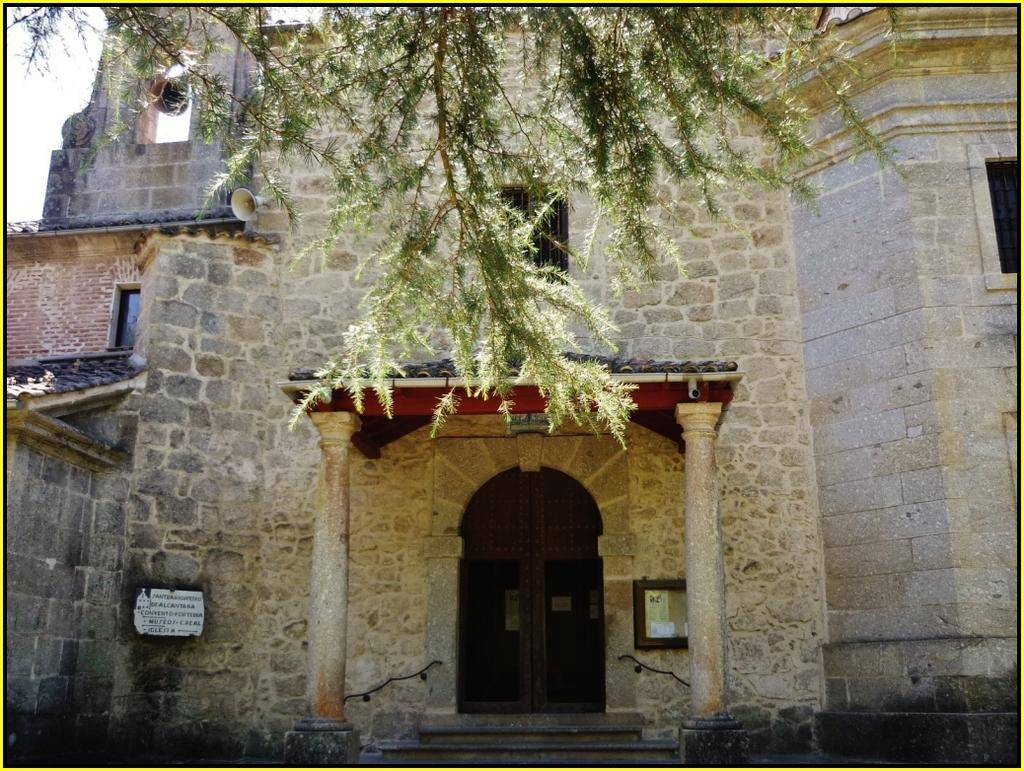What type of structure is present in the image? The image contains a building with windows. What object can be seen in the image that is typically used for amplifying sound? There is a megaphone in the image. What type of plant is visible in the image? There is a tree in the image. What part of the natural environment is visible in the image? The sky is visible at the top left corner of the image. What type of insect is crawling on the megaphone in the image? There is no insect present on the megaphone in the image. 